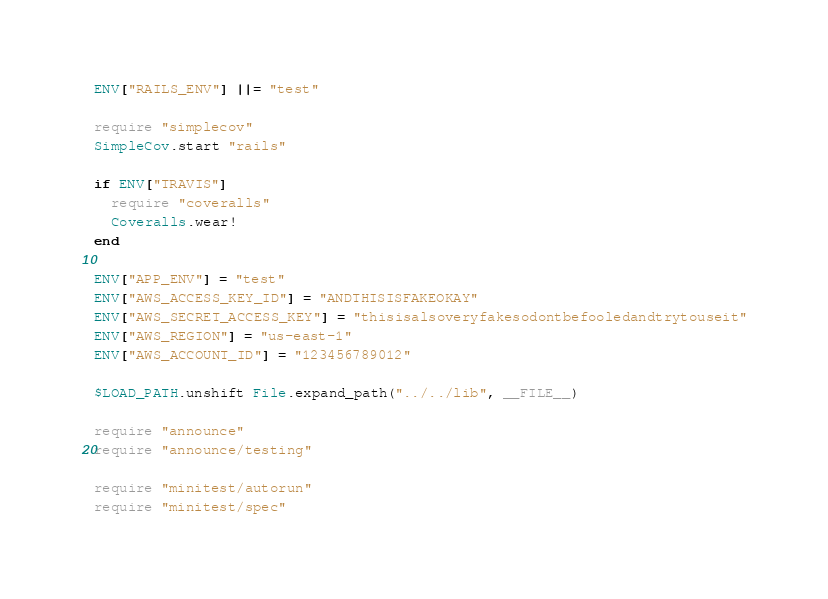<code> <loc_0><loc_0><loc_500><loc_500><_Ruby_>ENV["RAILS_ENV"] ||= "test"

require "simplecov"
SimpleCov.start "rails"

if ENV["TRAVIS"]
  require "coveralls"
  Coveralls.wear!
end

ENV["APP_ENV"] = "test"
ENV["AWS_ACCESS_KEY_ID"] = "ANDTHISISFAKEOKAY"
ENV["AWS_SECRET_ACCESS_KEY"] = "thisisalsoveryfakesodontbefooledandtrytouseit"
ENV["AWS_REGION"] = "us-east-1"
ENV["AWS_ACCOUNT_ID"] = "123456789012"

$LOAD_PATH.unshift File.expand_path("../../lib", __FILE__)

require "announce"
require "announce/testing"

require "minitest/autorun"
require "minitest/spec"</code> 